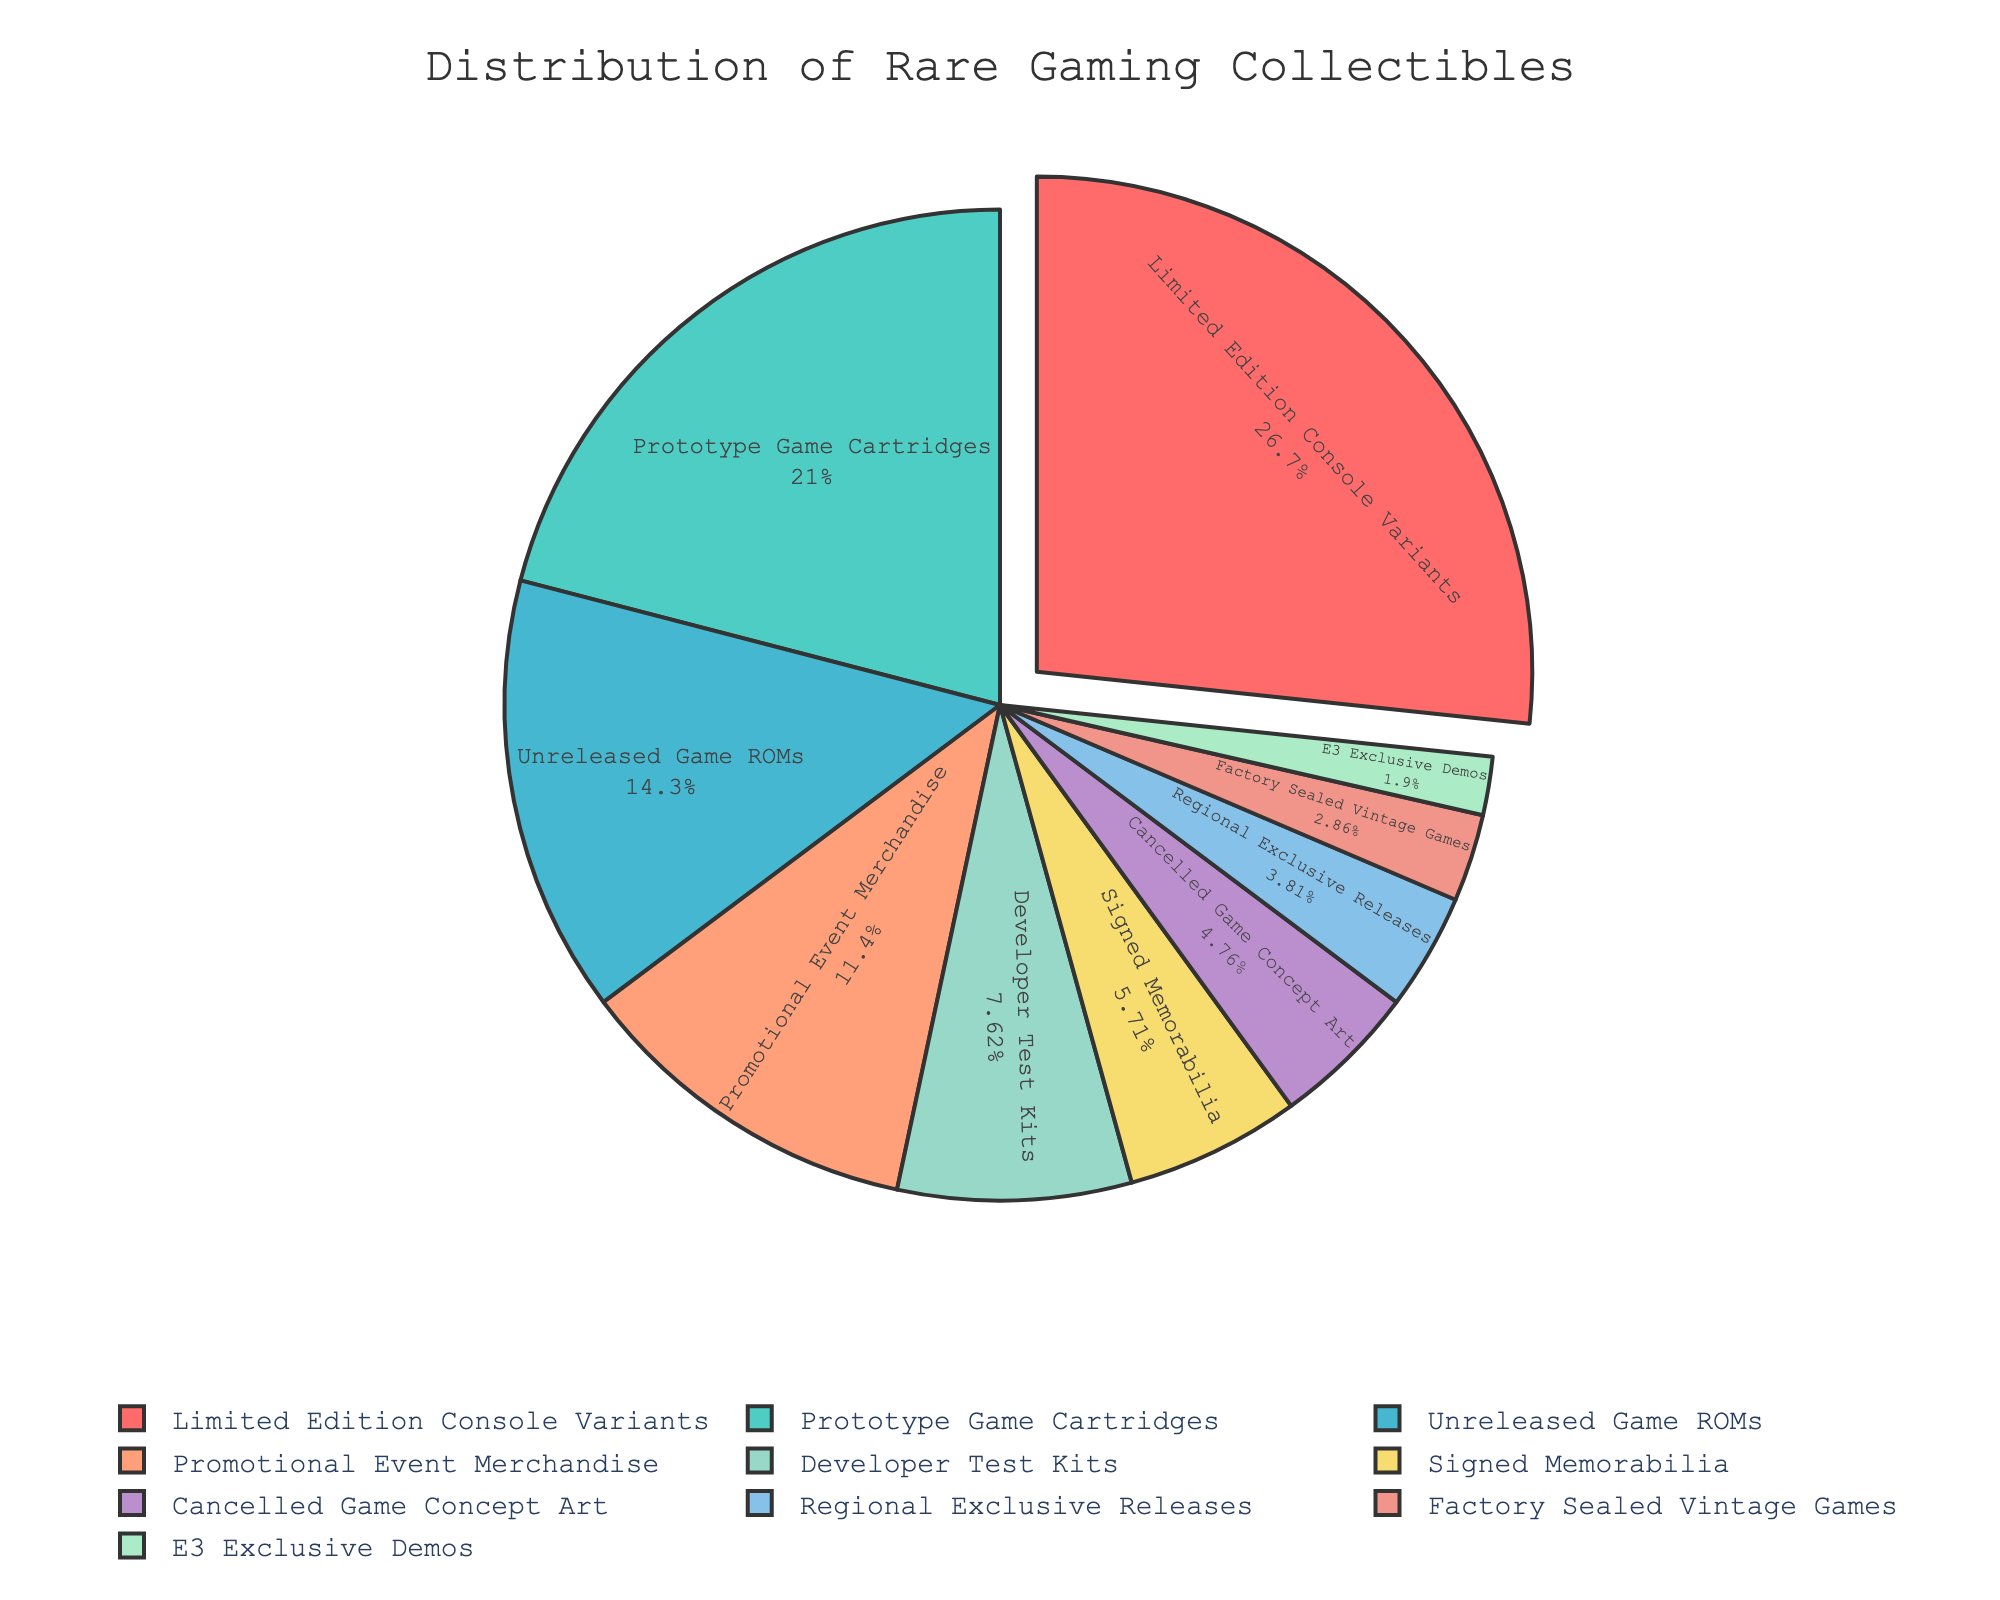Which type of collectible has the highest percentage? Look at the pie chart to identify the type with the largest wedge. The "Limited Edition Console Variants" occupies the largest space, making it the highest percentage.
Answer: Limited Edition Console Variants Which collectible type has the lowest percentage? Observe the smallest slice of the pie chart, which represents the type with the smallest percentage. The "E3 Exclusive Demos" is the smallest slice.
Answer: E3 Exclusive Demos What is the total percentage of Prototype Game Cartridges and Unreleased Game ROMs combined? Sum the percentages of "Prototype Game Cartridges" (22%) and "Unreleased Game ROMs" (15%). That is 22 + 15.
Answer: 37% How many collectible types have a percentage of 10% or higher? Review the pie chart and count the number of slices that have a percentage of 10% or more. The types are "Limited Edition Console Variants" (28%), "Prototype Game Cartridges" (22%), and "Unreleased Game ROMs" (15%), and "Promotional Event Merchandise" (12%).
Answer: 4 Which collectible types together make up exactly 20%? Find the types with percentages that add up to 20%. "Cancelled Game Concept Art" (5%) and "Regional Exclusive Releases" (4%) together are 9%, so include "Signed Memorabilia" (6%) to get 15%, then add "Factory Sealed Vintage Games" (3%) and "E3 Exclusive Demos" (2%) to achieve exactly 20%.
Answer: Signed Memorabilia and Cancelled Game Concept Art and Regional Exclusive Releases and Factory Sealed Vintage Games and E3 Exclusive Demos Is the combined percentage of Developer Test Kits and Factory Sealed Vintage Games greater than that of Promotional Event Merchandise? Compare the sum of "Developer Test Kits" (8%) and "Factory Sealed Vintage Games" (3%), which is 8+3=11%, to "Promotional Event Merchandise" at 12%.
Answer: No What is the average percentage of all collectible types in the chart? Sum up all percentages and divide by the number of types. The total is 28 + 22 + 15 + 12 + 8 + 6 + 5 + 4 + 3 + 2 = 105, divided by 10 types: 105/10.
Answer: 10.5% Which collectible type is shown in green? Identify the slice that is represented in green color in the pie chart. Here, "Prototype Game Cartridges" is colored green.
Answer: Prototype Game Cartridges Are there more collectible types below or above 10%? Count the number of types below and above 10%. Below 10% are Developer Test Kits, Signed Memorabilia, Cancelled Game Concept Art, Regional Exclusive Releases, Factory Sealed Vintage Games, and E3 Exclusive Demos (6 types). Above 10% are Limited Edition Console Variants, Prototype Game Cartridges, Unreleased Game ROMs, Promotional Event Merchandise (4 types).
Answer: More below Which types' combined percentage equal or exceed that of the Limited Edition Console Variants? Find the type(s) whose combined percentage is equal to or more than 28%. "Prototype Game Cartridges" (22%) and "Promotional Event Merchandise" (12%) combined are 22+12=34% which exceeds 28%. Also, "Unreleased Game ROMs" (15%) and "Promotional Event Merchandise" (12%) together are 27%, less than 28%; thus, the valid pair is "Prototype Game Cartridges" and "Promotional Event Merchandise".
Answer: Prototype Game Cartridges and Promotional Event Merchandise 